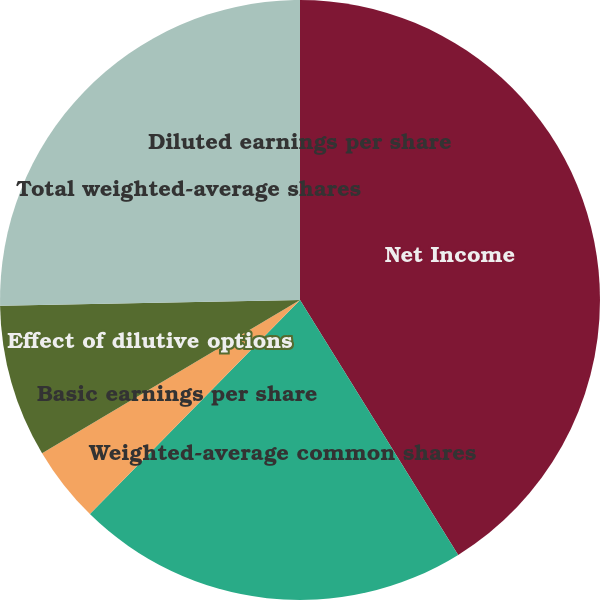Convert chart to OTSL. <chart><loc_0><loc_0><loc_500><loc_500><pie_chart><fcel>Net Income<fcel>Weighted-average common shares<fcel>Basic earnings per share<fcel>Effect of dilutive options<fcel>Total weighted-average shares<fcel>Diluted earnings per share<nl><fcel>41.16%<fcel>21.19%<fcel>4.12%<fcel>8.23%<fcel>25.3%<fcel>0.0%<nl></chart> 